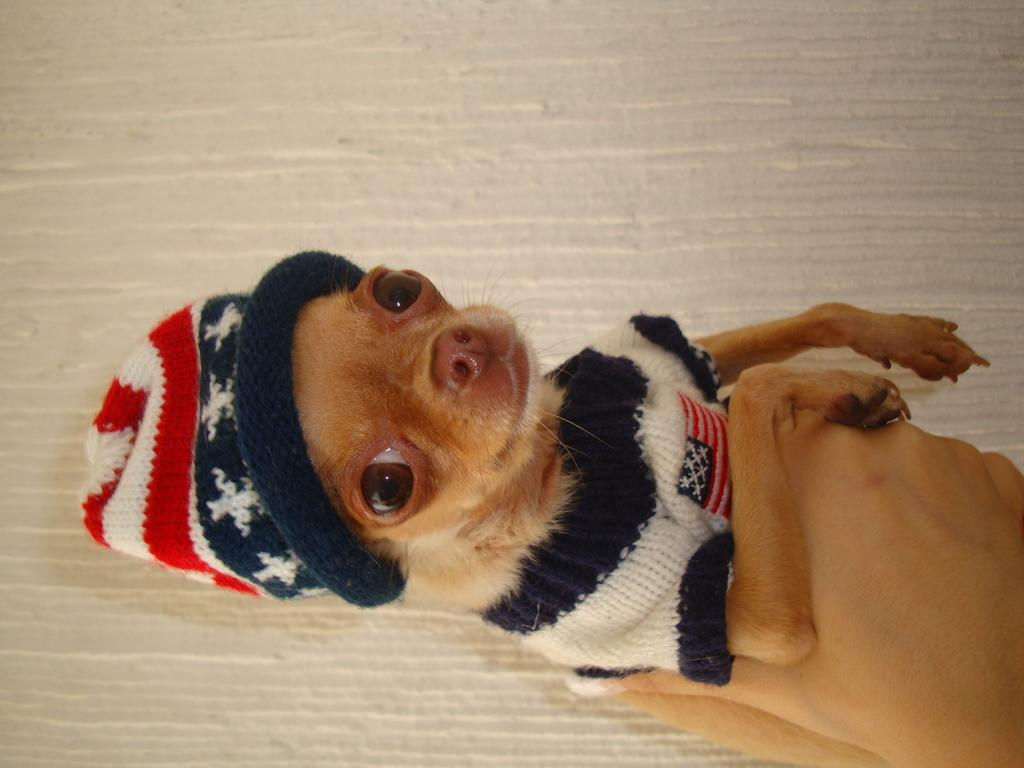What animal is present in the image? There is a dog in the image. What is the dog doing in the image? The dog is lying on the ground. What type of clothing is the dog wearing? The dog is wearing a woolen sweater and a cap. In which direction is the dog facing in the image? The provided facts do not specify the direction the dog is facing in the image. What type of insurance policy is the dog covered under in the image? There is no information about insurance policies in the image. 